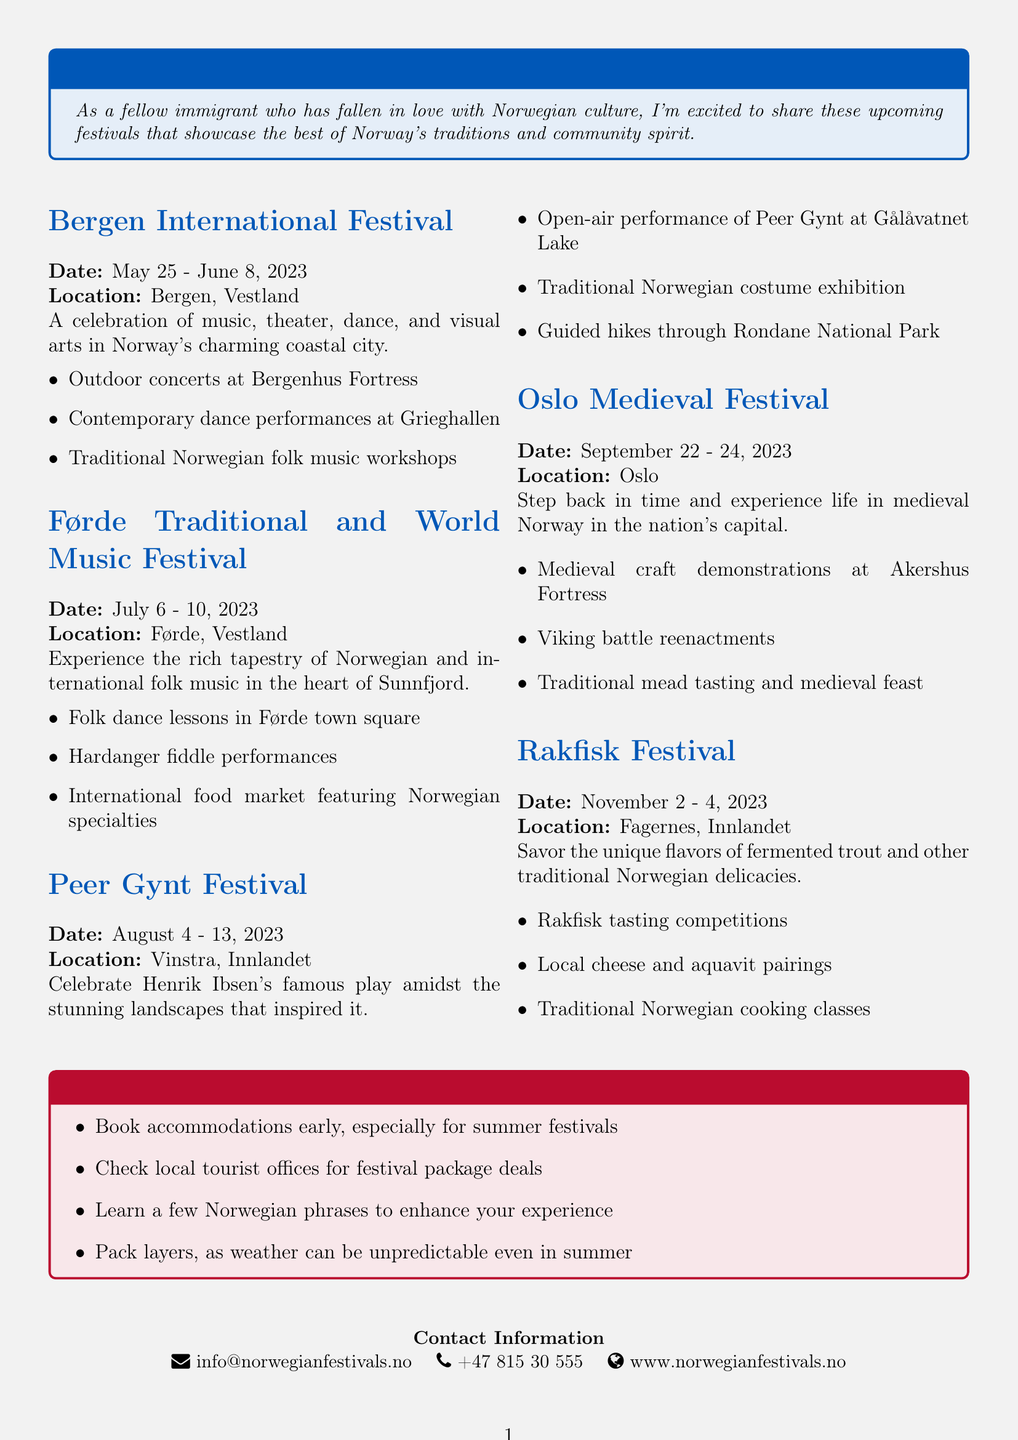What is the title of the brochure? The title of the brochure is explicitly stated at the beginning and is "Discover Norway's Vibrant Cultural Festivals."
Answer: Discover Norway's Vibrant Cultural Festivals When does the Bergen International Festival take place? The document specifies the exact dates for this festival, which are May 25 - June 8, 2023.
Answer: May 25 - June 8, 2023 What is one activity during the Oslo Medieval Festival? The document lists various activities, and one mentioned is "Viking battle reenactments."
Answer: Viking battle reenactments Where is the Rakfisk Festival located? The location for the Rakfisk Festival is clearly mentioned as Fagernes, Innlandet.
Answer: Fagernes, Innlandet How many days does the Peer Gynt Festival last? The start and end dates provide a clear duration, which is from August 4 to August 13, lasting 10 days.
Answer: 10 days What traditional activity is featured at the Førde Traditional and World Music Festival? One of the activities listed is "Hardanger fiddle performances," which highlights traditional music.
Answer: Hardanger fiddle performances What tip is given for traveling during the festivals? One of the travel tips advises to "Book accommodations early, especially for summer festivals."
Answer: Book accommodations early What is the contact email provided in the brochure? The contact information section specifies the email address as info@norwegianfestivals.no.
Answer: info@norwegianfestivals.no 